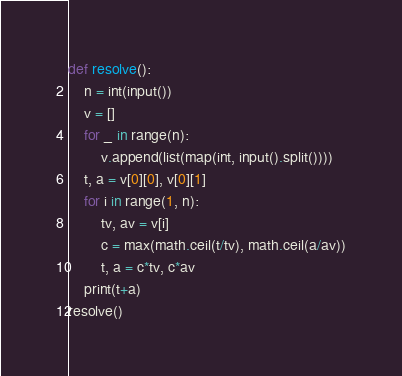<code> <loc_0><loc_0><loc_500><loc_500><_Python_>def resolve():
	n = int(input())
	v = []
	for _ in range(n):
		v.append(list(map(int, input().split())))
	t, a = v[0][0], v[0][1]
	for i in range(1, n):
		tv, av = v[i]
		c = max(math.ceil(t/tv), math.ceil(a/av))
		t, a = c*tv, c*av
	print(t+a)
resolve()</code> 